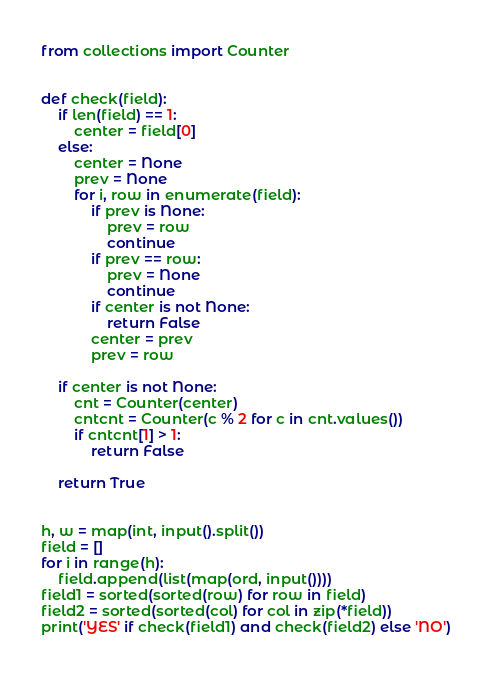<code> <loc_0><loc_0><loc_500><loc_500><_Python_>from collections import Counter


def check(field):
    if len(field) == 1:
        center = field[0]
    else:
        center = None
        prev = None
        for i, row in enumerate(field):
            if prev is None:
                prev = row
                continue
            if prev == row:
                prev = None
                continue
            if center is not None:
                return False
            center = prev
            prev = row

    if center is not None:
        cnt = Counter(center)
        cntcnt = Counter(c % 2 for c in cnt.values())
        if cntcnt[1] > 1:
            return False

    return True


h, w = map(int, input().split())
field = []
for i in range(h):
    field.append(list(map(ord, input())))
field1 = sorted(sorted(row) for row in field)
field2 = sorted(sorted(col) for col in zip(*field))
print('YES' if check(field1) and check(field2) else 'NO')
</code> 